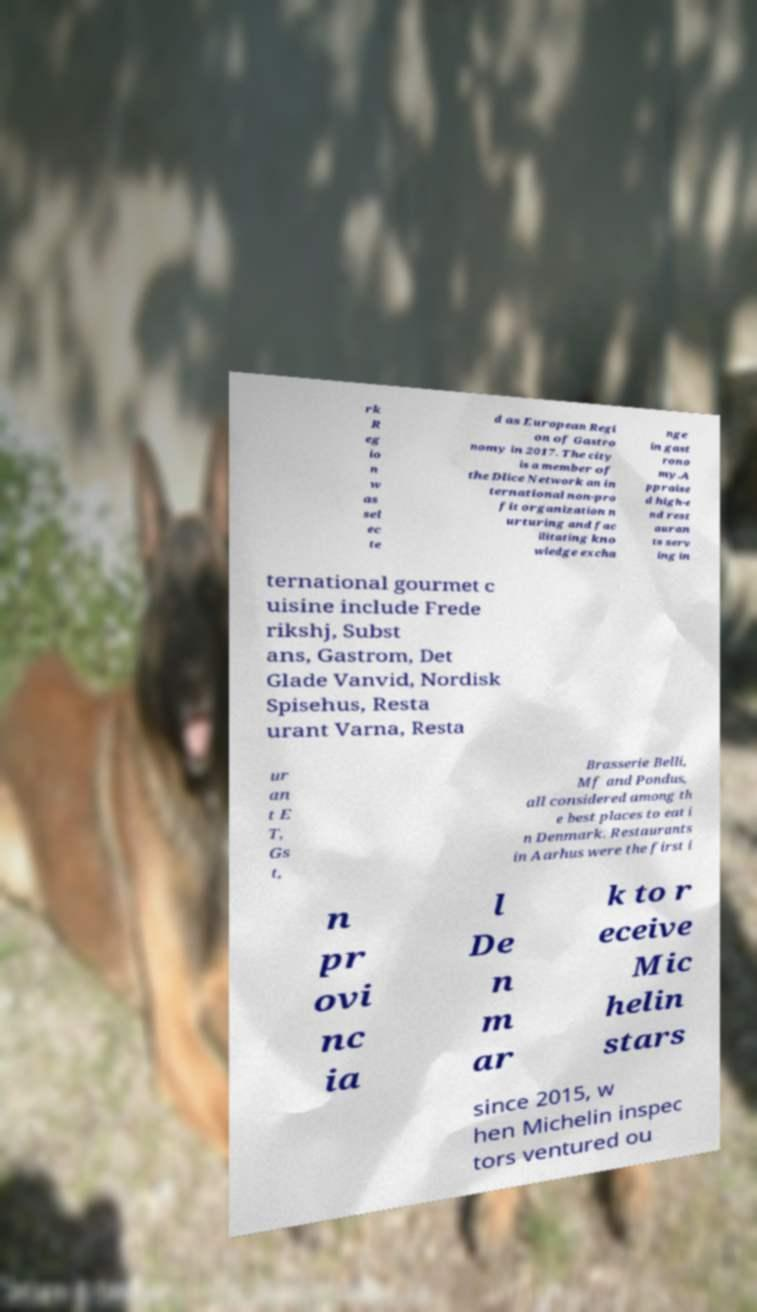Could you assist in decoding the text presented in this image and type it out clearly? rk R eg io n w as sel ec te d as European Regi on of Gastro nomy in 2017. The city is a member of the Dlice Network an in ternational non-pro fit organization n urturing and fac ilitating kno wledge excha nge in gast rono my.A ppraise d high-e nd rest auran ts serv ing in ternational gourmet c uisine include Frede rikshj, Subst ans, Gastrom, Det Glade Vanvid, Nordisk Spisehus, Resta urant Varna, Resta ur an t E T, Gs t, Brasserie Belli, Mf and Pondus, all considered among th e best places to eat i n Denmark. Restaurants in Aarhus were the first i n pr ovi nc ia l De n m ar k to r eceive Mic helin stars since 2015, w hen Michelin inspec tors ventured ou 